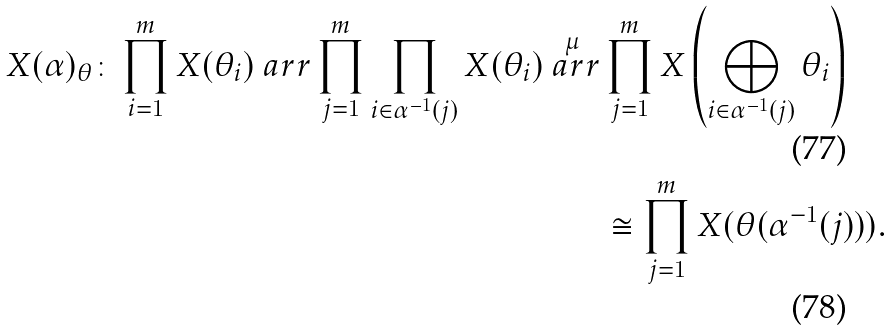<formula> <loc_0><loc_0><loc_500><loc_500>X ( \alpha ) _ { \theta } \colon \prod _ { i = 1 } ^ { m } X ( \theta _ { i } ) \ a r r \prod _ { j = 1 } ^ { m } \prod _ { i \in \alpha ^ { - 1 } ( j ) } X ( \theta _ { i } ) \overset { \mu } { \ a r r } & \prod _ { j = 1 } ^ { m } X \left ( \bigoplus _ { i \in \alpha ^ { - 1 } ( j ) } \theta _ { i } \right ) \\ & \cong \prod _ { j = 1 } ^ { m } X ( \theta ( \alpha ^ { - 1 } ( j ) ) ) .</formula> 